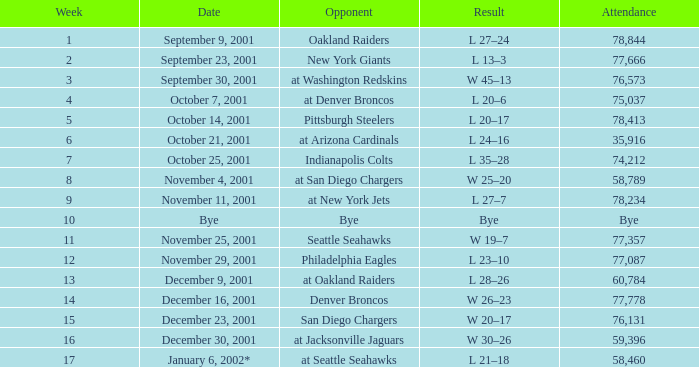What week is a bye week? 10.0. Write the full table. {'header': ['Week', 'Date', 'Opponent', 'Result', 'Attendance'], 'rows': [['1', 'September 9, 2001', 'Oakland Raiders', 'L 27–24', '78,844'], ['2', 'September 23, 2001', 'New York Giants', 'L 13–3', '77,666'], ['3', 'September 30, 2001', 'at Washington Redskins', 'W 45–13', '76,573'], ['4', 'October 7, 2001', 'at Denver Broncos', 'L 20–6', '75,037'], ['5', 'October 14, 2001', 'Pittsburgh Steelers', 'L 20–17', '78,413'], ['6', 'October 21, 2001', 'at Arizona Cardinals', 'L 24–16', '35,916'], ['7', 'October 25, 2001', 'Indianapolis Colts', 'L 35–28', '74,212'], ['8', 'November 4, 2001', 'at San Diego Chargers', 'W 25–20', '58,789'], ['9', 'November 11, 2001', 'at New York Jets', 'L 27–7', '78,234'], ['10', 'Bye', 'Bye', 'Bye', 'Bye'], ['11', 'November 25, 2001', 'Seattle Seahawks', 'W 19–7', '77,357'], ['12', 'November 29, 2001', 'Philadelphia Eagles', 'L 23–10', '77,087'], ['13', 'December 9, 2001', 'at Oakland Raiders', 'L 28–26', '60,784'], ['14', 'December 16, 2001', 'Denver Broncos', 'W 26–23', '77,778'], ['15', 'December 23, 2001', 'San Diego Chargers', 'W 20–17', '76,131'], ['16', 'December 30, 2001', 'at Jacksonville Jaguars', 'W 30–26', '59,396'], ['17', 'January 6, 2002*', 'at Seattle Seahawks', 'L 21–18', '58,460']]} 